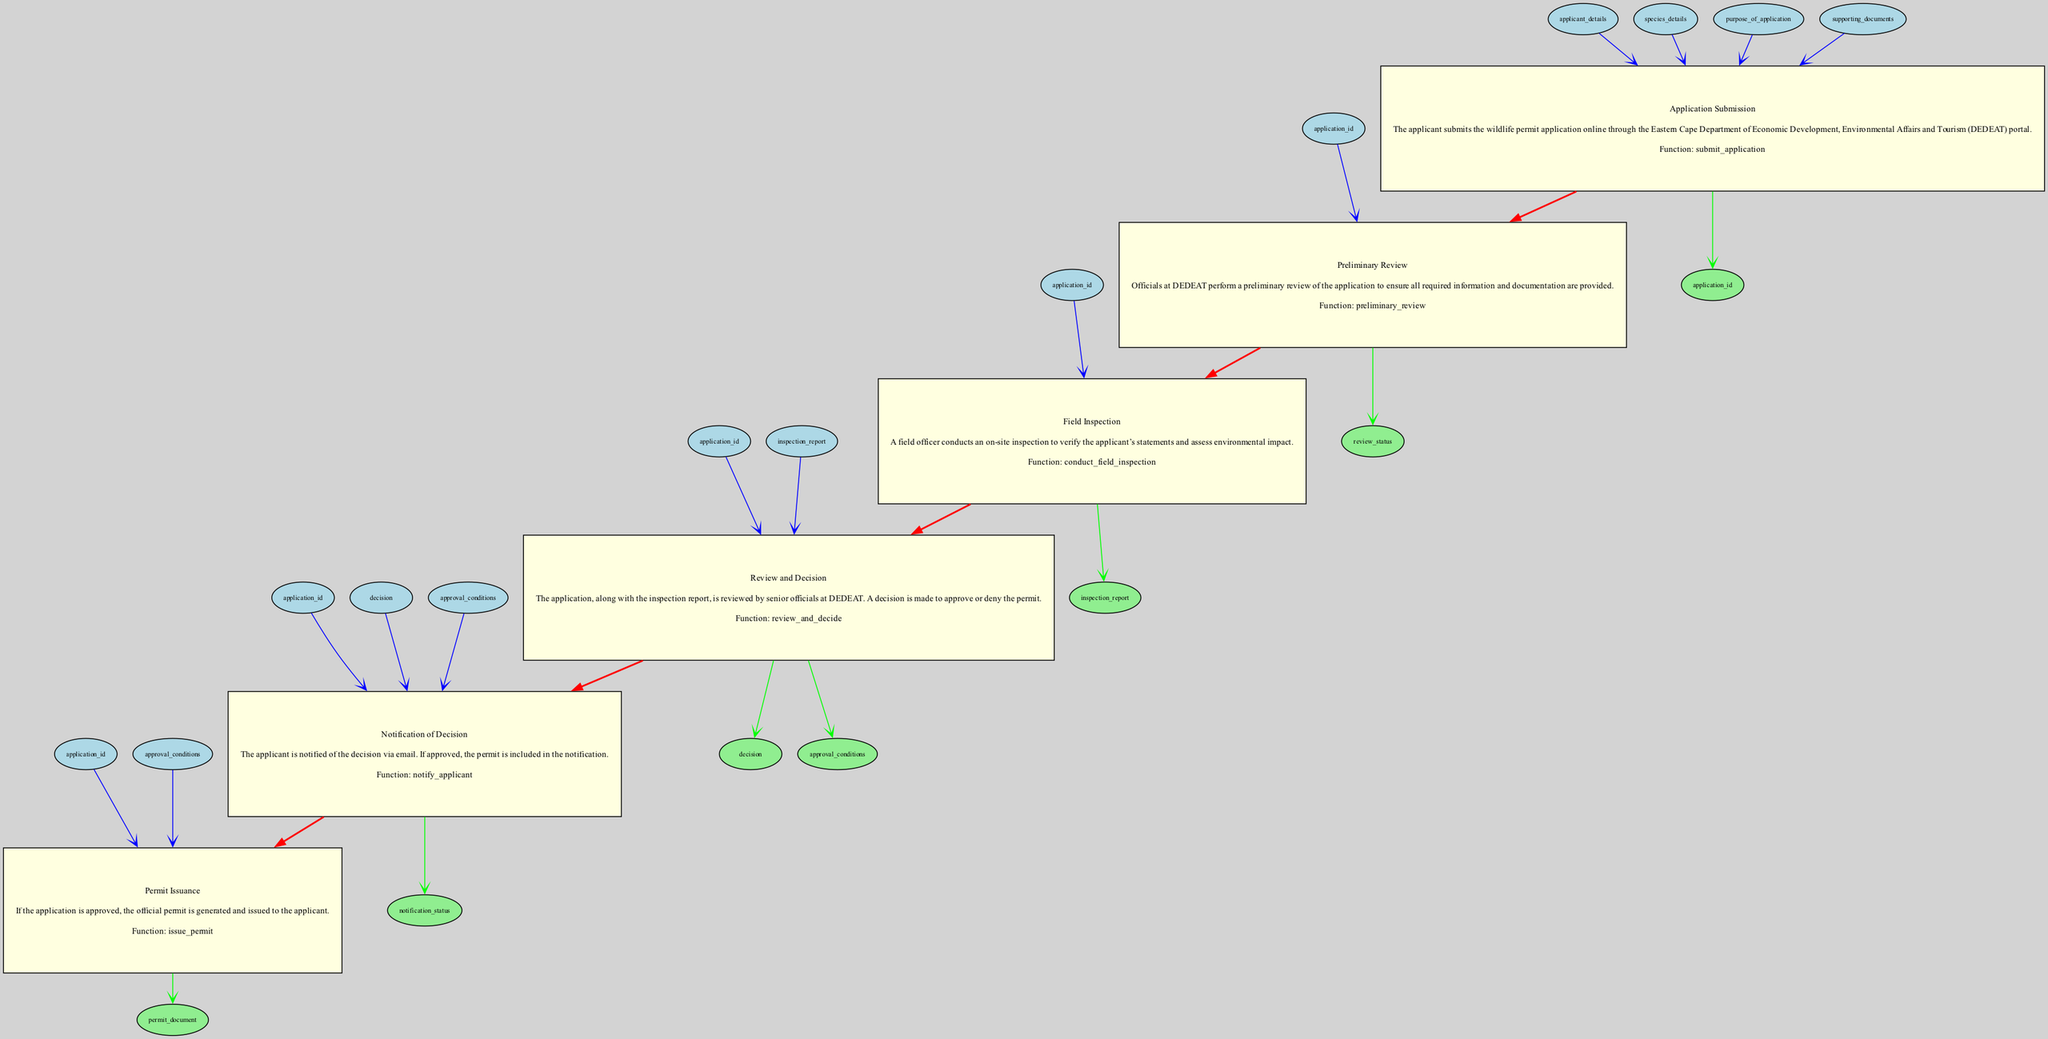What is the first step in the wildlife permit application process? The first step in the diagram is "Application Submission," which outlines that the applicant submits the wildlife permit application online.
Answer: Application Submission How many inputs does the "Field Inspection" step have? The "Field Inspection" has one input, which is "application_id," as indicated in the diagram.
Answer: 1 What is the output of the "Preliminary Review"? The output of the "Preliminary Review" step is "review_status," as it is specified in the outputs for that step in the diagram.
Answer: review_status Which step follows "Field Inspection"? According to the flow of the diagram, "Review and Decision" follows "Field Inspection," as each step is connected in order.
Answer: Review and Decision What document is issued if the permit application is approved? The document issued upon approval of the permit application is referred to as "permit_document" in the diagram.
Answer: permit_document How many total steps are involved in the wildlife permit application process? The diagram specifies a total of six steps from "Application Submission" to "Permit Issuance," thus summing them gives the total.
Answer: 6 Which step includes notifying the applicant? The step titled "Notification of Decision" includes the process of notifying the applicant, as described in the diagram.
Answer: Notification of Decision What is the main purpose of the "Field Inspection"? The main purpose of the "Field Inspection" is to verify the applicant’s statements and assess environmental impact, as mentioned in the description of that step.
Answer: Verify statements What is a requirement before continuing to the "Review and Decision" step? The requirement is that the "Field Inspection" must be conducted and its report must be available before moving on to "Review and Decision."
Answer: Field Inspection report 